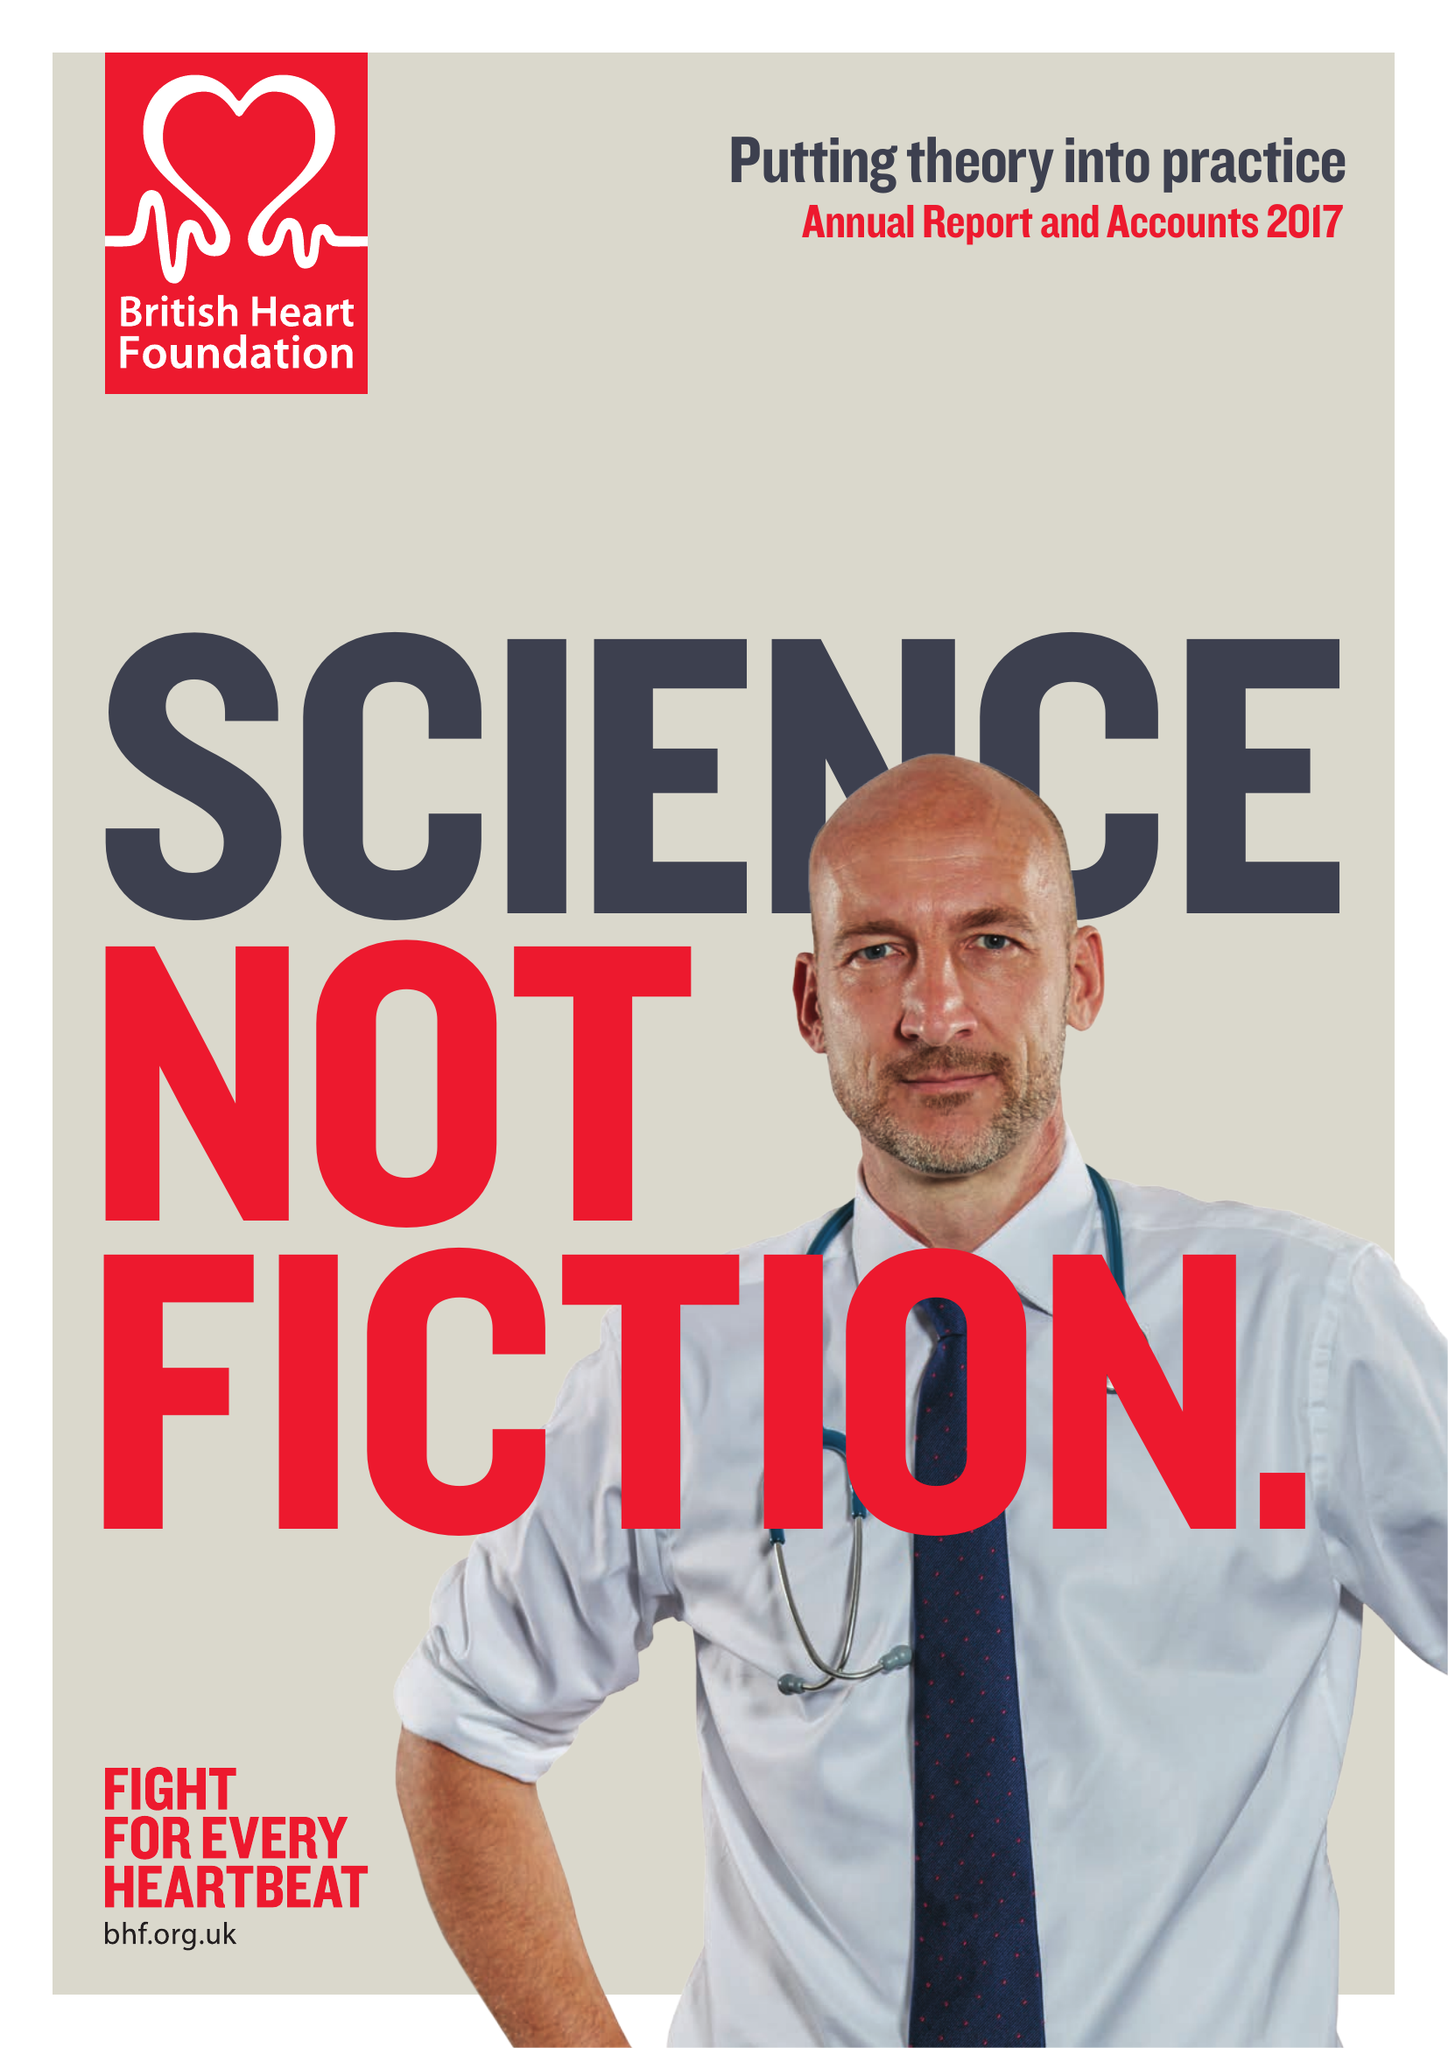What is the value for the spending_annually_in_british_pounds?
Answer the question using a single word or phrase. 317000000.00 